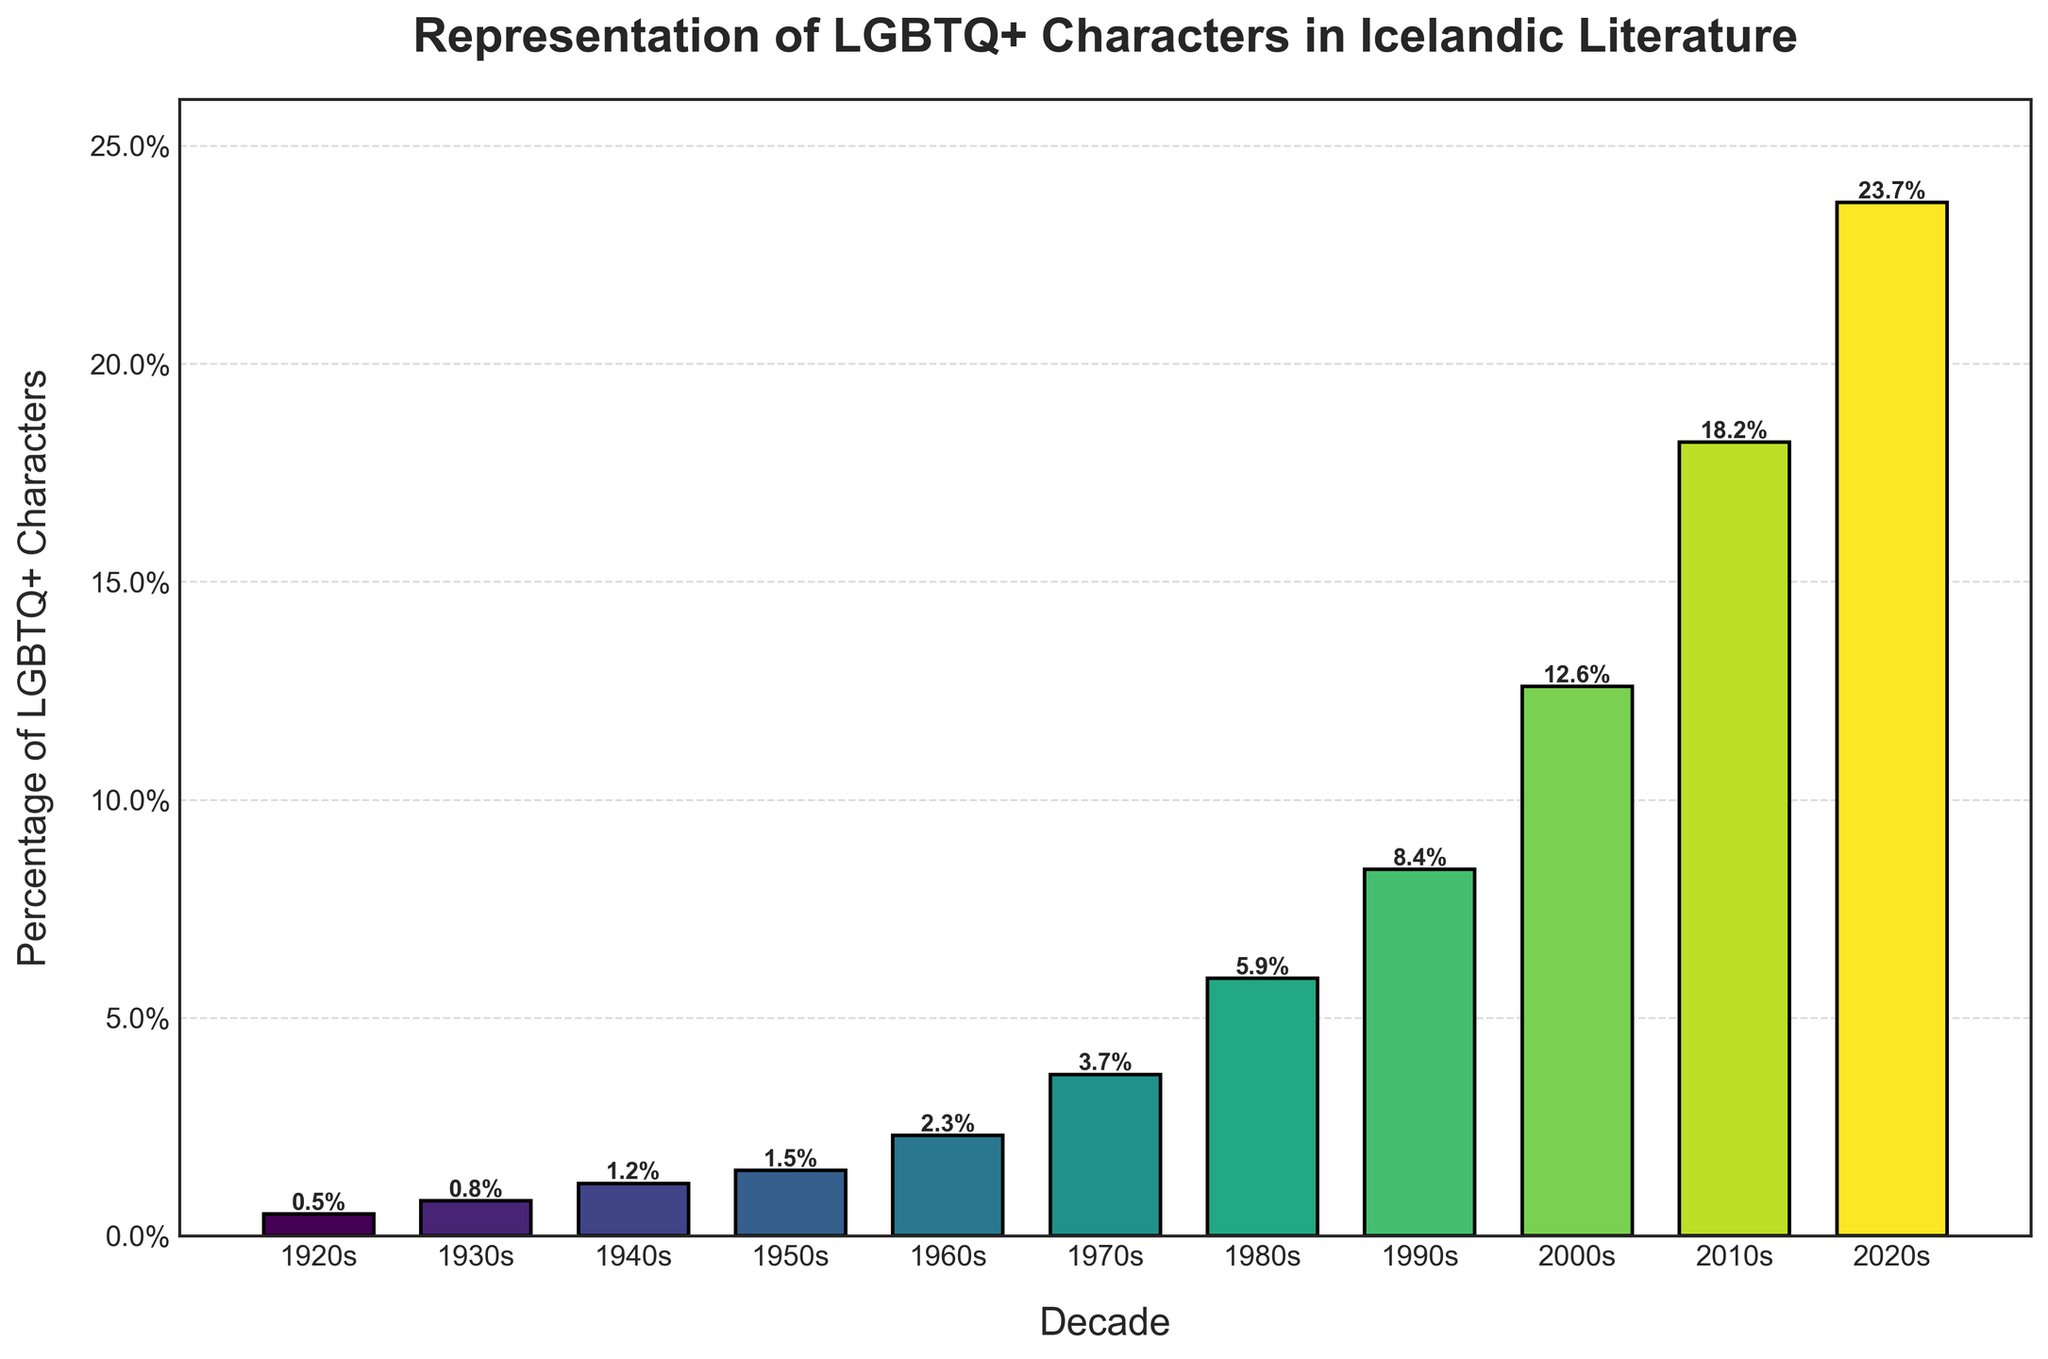What is the percentage of LGBTQ+ characters in Icelandic literature in the 1980s? Find the bar corresponding to the 1980s and read the height of the bar, which is labeled at the top.
Answer: 5.9% Which decade shows the highest percentage of LGBTQ+ characters? Identify the tallest bar in the chart and read the corresponding decade from the label beneath the bar.
Answer: 2020s By how much did the percentage of LGBTQ+ characters increase from the 1920s to the 1950s? Subtract the percentage in the 1920s (0.5%) from the percentage in the 1950s (1.5%). 1.5 - 0.5 = 1.0
Answer: 1.0% What's the average percentage of LGBTQ+ characters from the 1960s through the 1980s? Add the percentages for the 1960s (2.3%), 1970s (3.7%), and 1980s (5.9%) and divide by the number of decades: (2.3 + 3.7 + 5.9) / 3 = 3.97
Answer: 3.97% Which decade experienced the largest increase in the percentage of LGBTQ+ characters compared to the previous decade? Calculate the difference in percentages for each pair of consecutive decades and find the largest difference. 1930s-1920s: 0.8-0.5=0.3, 1940s-1930s: 1.2-0.8=0.4, ..., 2020s-2010s: 23.7-18.2=5.5. The largest increase is 5.5%
Answer: 2020s-2010s Is the percentage of LGBTQ+ characters more than double in the 2000s compared to the 1980s? Calculate twice the percentage in the 1980s (2 * 5.9 = 11.8). Compare it to the percentage in the 2000s (12.6%). Since 12.6% > 11.8%, the percentage more than doubled.
Answer: Yes By examining the chart, how many decades show a percentage of LGBTQ+ characters below 5%? Count the number of bars with heights less than 5%. These are the bars from the 1920s to the 1970s.
Answer: 5 What is the overall trend observed in the representation of LGBTQ+ characters in Icelandic literature from the 1920s to the 2020s? Visually inspect the chart and note the increasing height of the bars over the decades, indicating a rising trend.
Answer: Increasing If you combine the percentages of the LGBTQ+ characters from the 1920s to the 1950s, what is the total percentage? Sum the percentages from the 1920s (0.5%), 1930s (0.8%), 1940s (1.2%), and 1950s (1.5%). 0.5 + 0.8 + 1.2 + 1.5 = 4.0
Answer: 4.0% Looking at the trend, can we say the percentage of LGBTQ+ characters doubled every decade starting from the 1980s onwards? Compare each decade's percentage with twice that of the previous decade: 1980s (5.9%), 1990s (8.4), 2000s (12.6), 2010s (18.2), and 2020s (23.7). Check if each value is roughly double the previous decade's percentage, which is not consistently the case.
Answer: No 